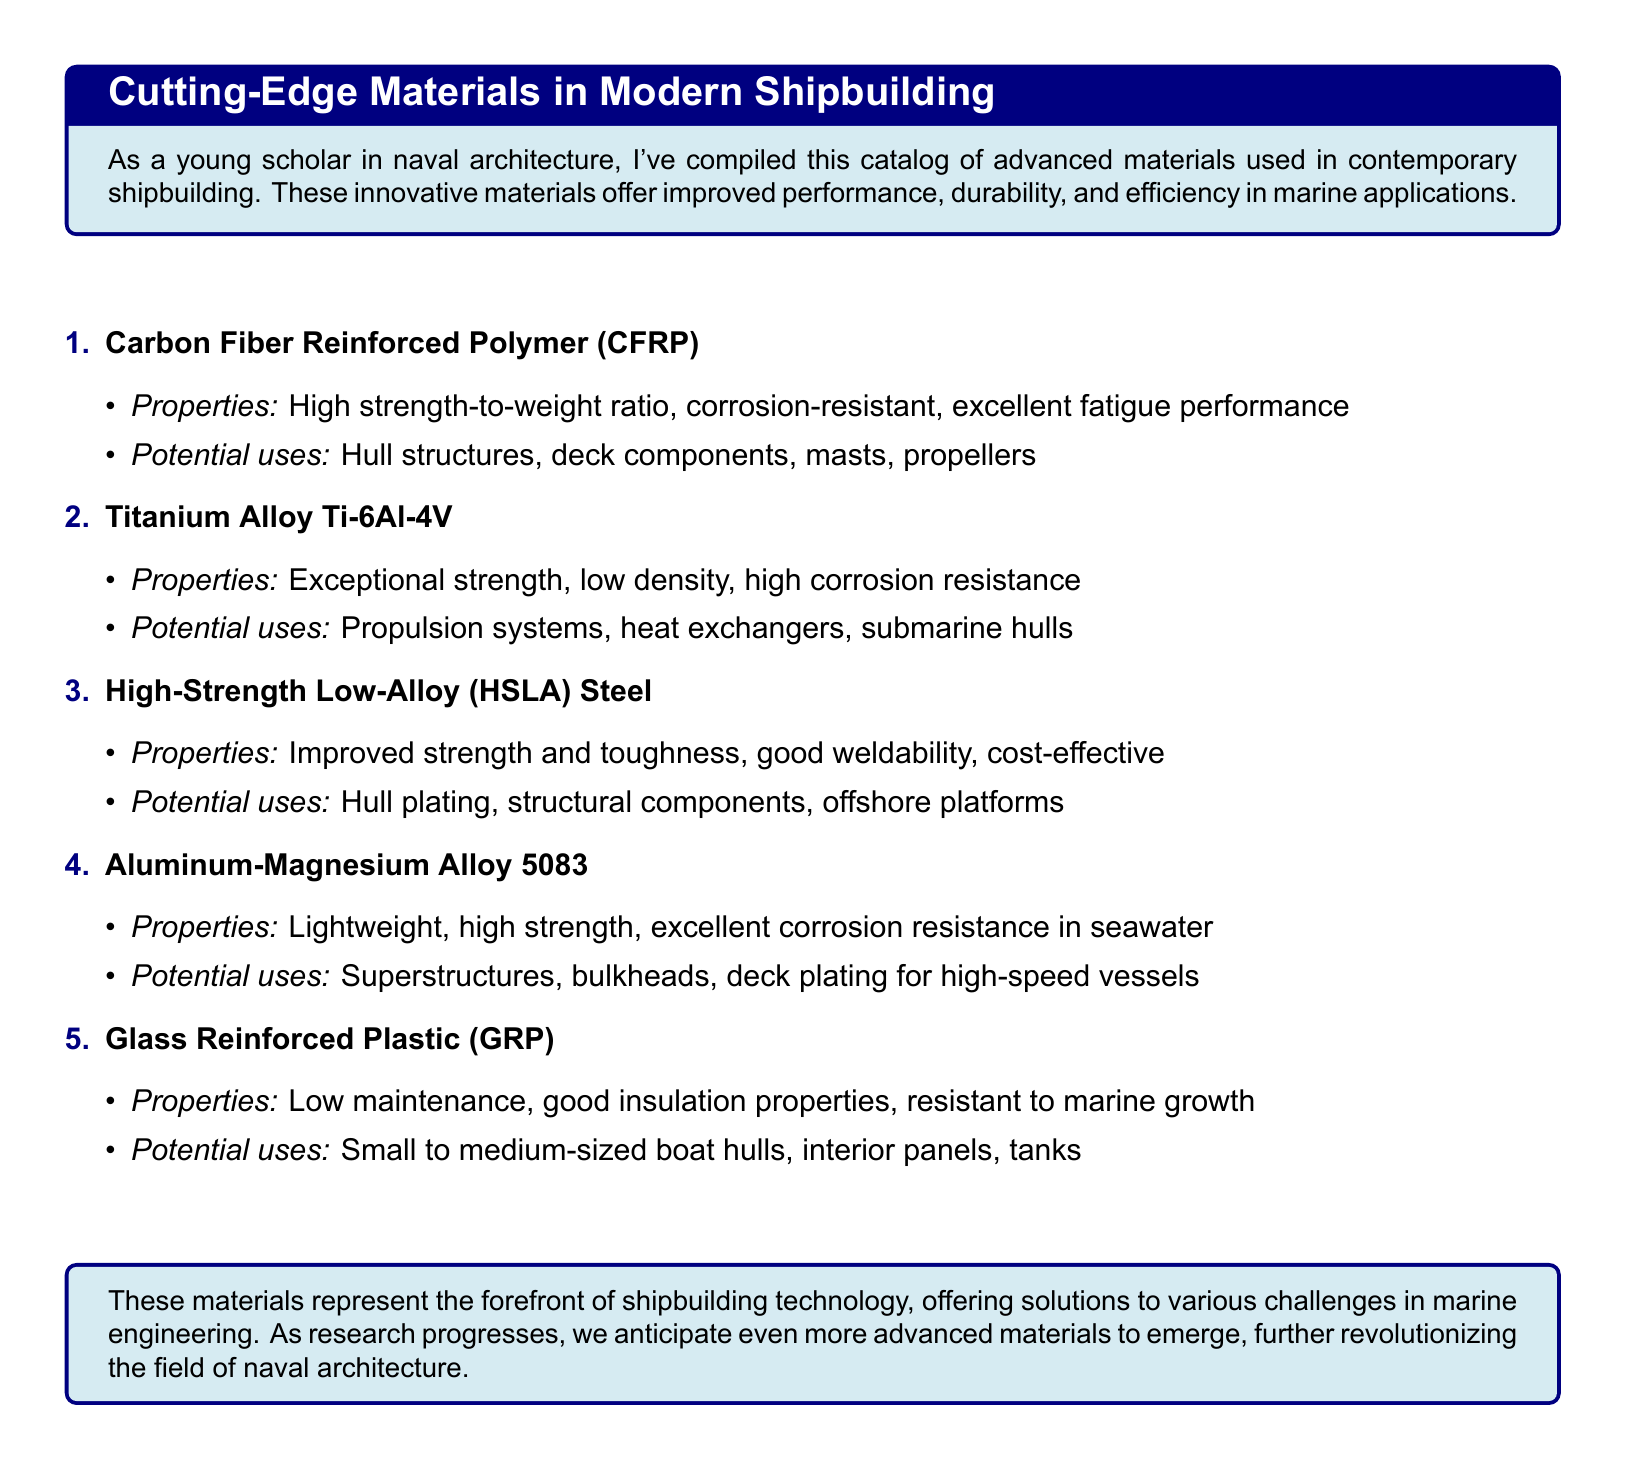What is the first material listed in the catalog? The first material is identified in the enumerated list of materials, which is Carbon Fiber Reinforced Polymer (CFRP).
Answer: Carbon Fiber Reinforced Polymer (CFRP) What is a property of Titanium Alloy Ti-6Al-4V? The properties are listed under each material, and one of them is exceptional strength.
Answer: Exceptional strength What potential use is listed for High-Strength Low-Alloy (HSLA) Steel? The potential uses are detailed in the document, with one being hull plating.
Answer: Hull plating How many materials are described in the catalog? The catalog contains five materials that are enumerated and described.
Answer: Five What are Aluminum-Magnesium Alloy 5083's main properties? The properties are listed, and they are lightweight and high strength.
Answer: Lightweight, high strength Which material is characterized by low maintenance? The material's properties include low maintenance and good insulation properties, which applies to Glass Reinforced Plastic (GRP).
Answer: Glass Reinforced Plastic (GRP) Which material is noted for excellent fatigue performance? The property of excellent fatigue performance is associated with Carbon Fiber Reinforced Polymer (CFRP).
Answer: Carbon Fiber Reinforced Polymer (CFRP) What is a common application for Glass Reinforced Plastic (GRP)? The potential uses include small to medium-sized boat hulls, as specified in the document.
Answer: Small to medium-sized boat hulls What type of document is this? The structure and content, including material properties and uses, suggest it is a catalog.
Answer: Catalog 